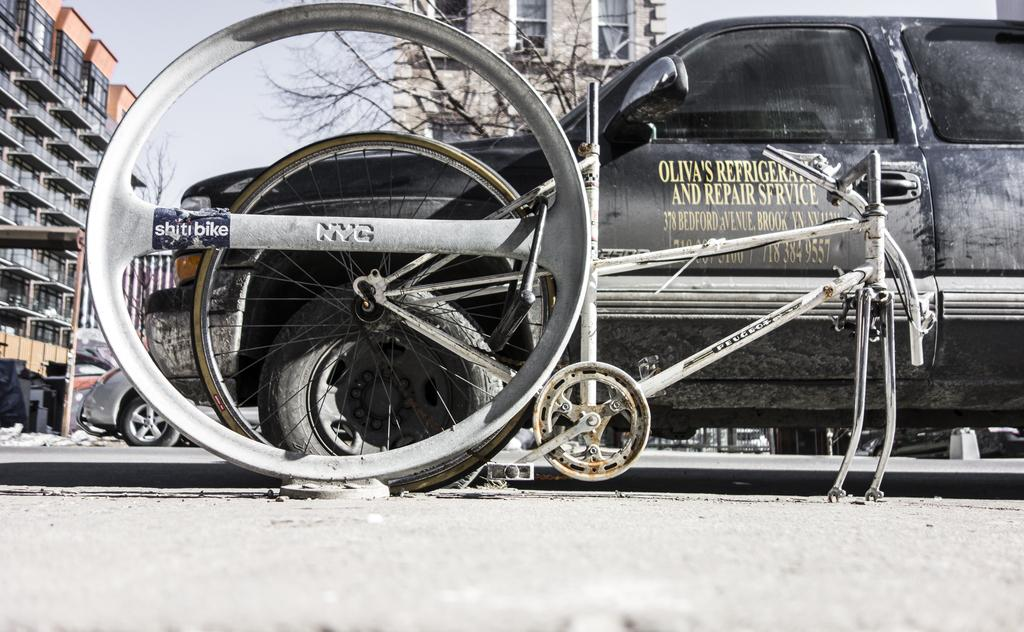What is present on the road in the image? There are vehicles on the road in the image. What can be seen behind the vehicles? There are trees and buildings visible behind the vehicles. What is visible in the sky in the image? The sky is visible in the image. How many eyes can be seen on the vehicles in the image? There are no eyes visible on the vehicles in the image, as vehicles do not have eyes. 